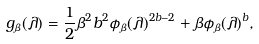Convert formula to latex. <formula><loc_0><loc_0><loc_500><loc_500>g _ { \beta } ( \lambda ) = \frac { 1 } { 2 } \beta ^ { 2 } b ^ { 2 } \phi _ { \beta } ( \lambda ) ^ { 2 b - 2 } + \beta \phi _ { \beta } ( \lambda ) ^ { b } ,</formula> 